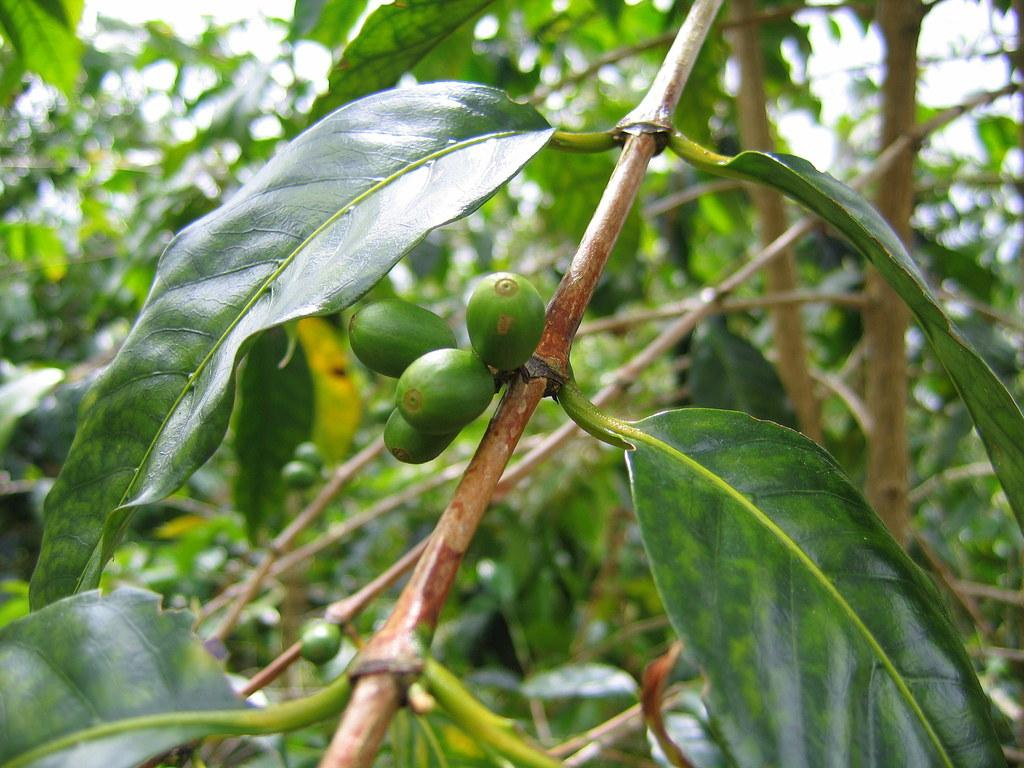What is the main subject of the image? The main subject of the image is a stem with leaves and fruits. What color are the fruits on the stem? The fruits on the stem are green in color. What can be seen in the background of the image? There are many plants in the background of the image. What type of wax is used to create the fruits in the image? There is no wax used to create the fruits in the image; they are real fruits on a stem. What belief is depicted in the image? There is no specific belief depicted in the image; it is a photograph of a stem with leaves and fruits. 